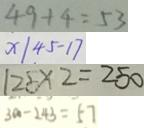<formula> <loc_0><loc_0><loc_500><loc_500>4 9 + 4 = 5 3 
 x \vert 4 5 - 1 7 
 1 2 5 \times 2 = 2 5 0 
 3 0 0 - 2 4 3 = 5 7</formula> 